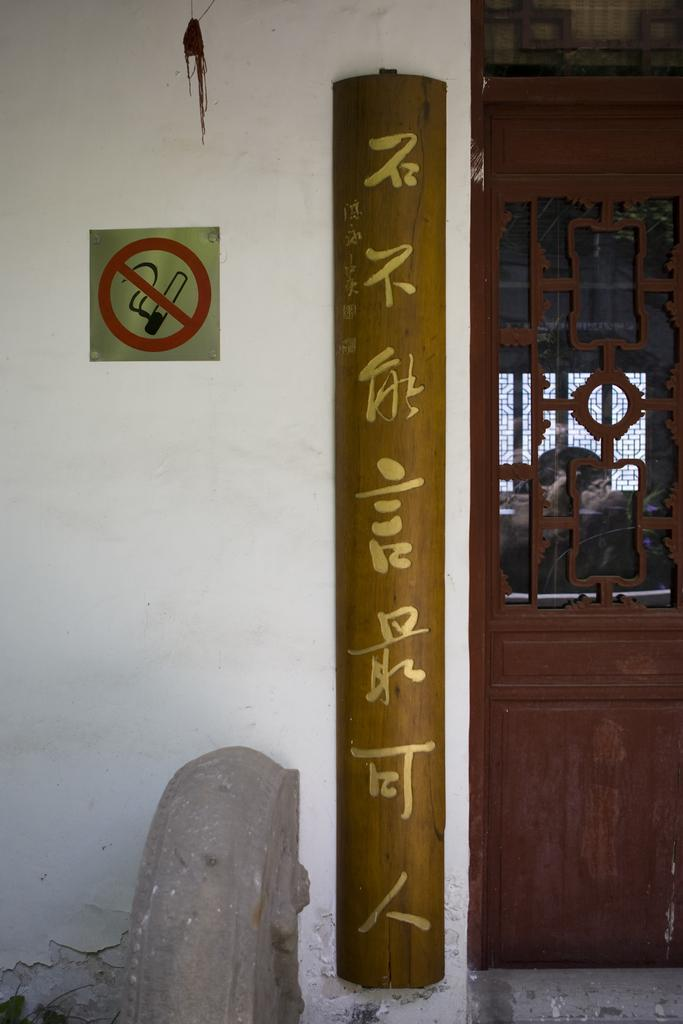What is the main structure visible in the image? There is a wall in the image. Are there any openings in the wall? Yes, there is a door in the wall. What type of material is used for an object attached to the wall? There is an object made of wood attached to the wall. What is attached to the wall besides the wooden object? There is a board attached to the wall. How many beds can be seen in the image? There are no beds present in the image. What is the porter doing in the image? There is no porter present in the image. 